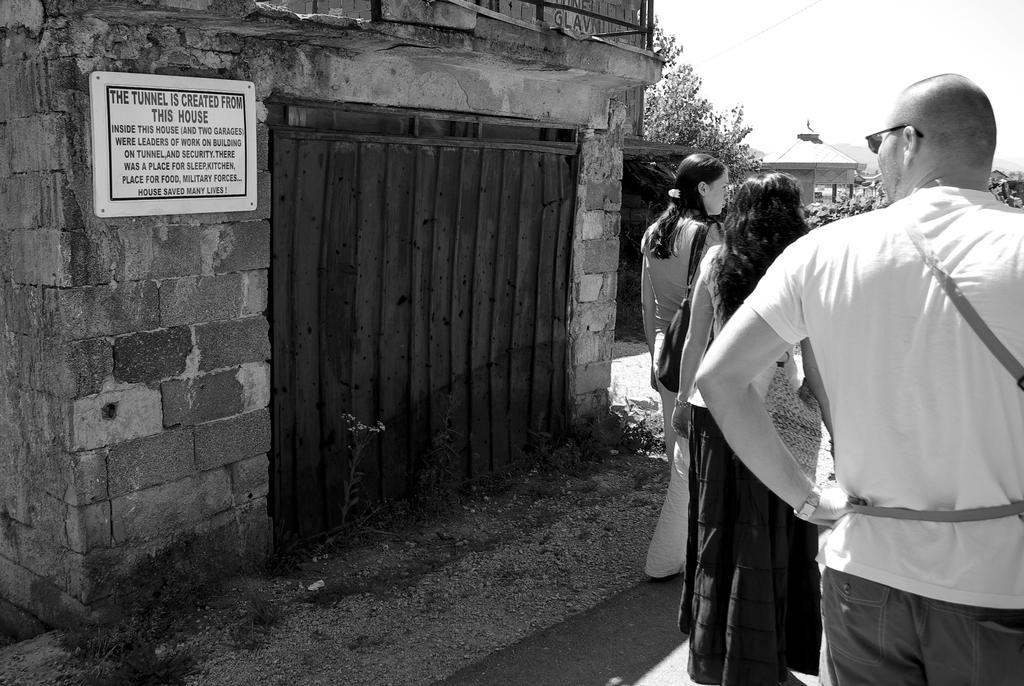Please provide a concise description of this image. Black and white picture. Board is on the brick wall. Here we can see people. 